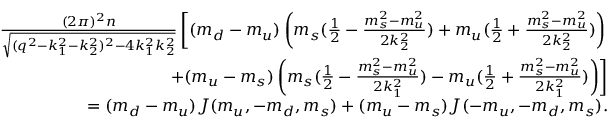<formula> <loc_0><loc_0><loc_500><loc_500>\begin{array} { r l r } & { \frac { ( 2 \pi ) ^ { 2 } n } { \sqrt { ( q ^ { 2 } - k _ { 1 } ^ { 2 } - k _ { 2 } ^ { 2 } ) ^ { 2 } - 4 k _ { 1 } ^ { 2 } k _ { 2 } ^ { 2 } } } \left [ ( m _ { d } - m _ { u } ) \left ( m _ { s } ( \frac { 1 } { 2 } - \frac { m _ { s } ^ { 2 } - m _ { u } ^ { 2 } } { 2 k _ { 2 } ^ { 2 } } ) + m _ { u } ( \frac { 1 } { 2 } + \frac { m _ { s } ^ { 2 } - m _ { u } ^ { 2 } } { 2 k _ { 2 } ^ { 2 } } ) \right ) } \\ & { + ( m _ { u } - m _ { s } ) \left ( m _ { s } ( \frac { 1 } { 2 } - \frac { m _ { s } ^ { 2 } - m _ { u } ^ { 2 } } { 2 k _ { 1 } ^ { 2 } } ) - m _ { u } ( \frac { 1 } { 2 } + \frac { m _ { s } ^ { 2 } - m _ { u } ^ { 2 } } { 2 k _ { 1 } ^ { 2 } } ) \right ) \right ] } \\ & { = ( m _ { d } - m _ { u } ) J ( m _ { u } , - m _ { d } , m _ { s } ) + ( m _ { u } - m _ { s } ) J ( - m _ { u } , - m _ { d } , m _ { s } ) . } \end{array}</formula> 